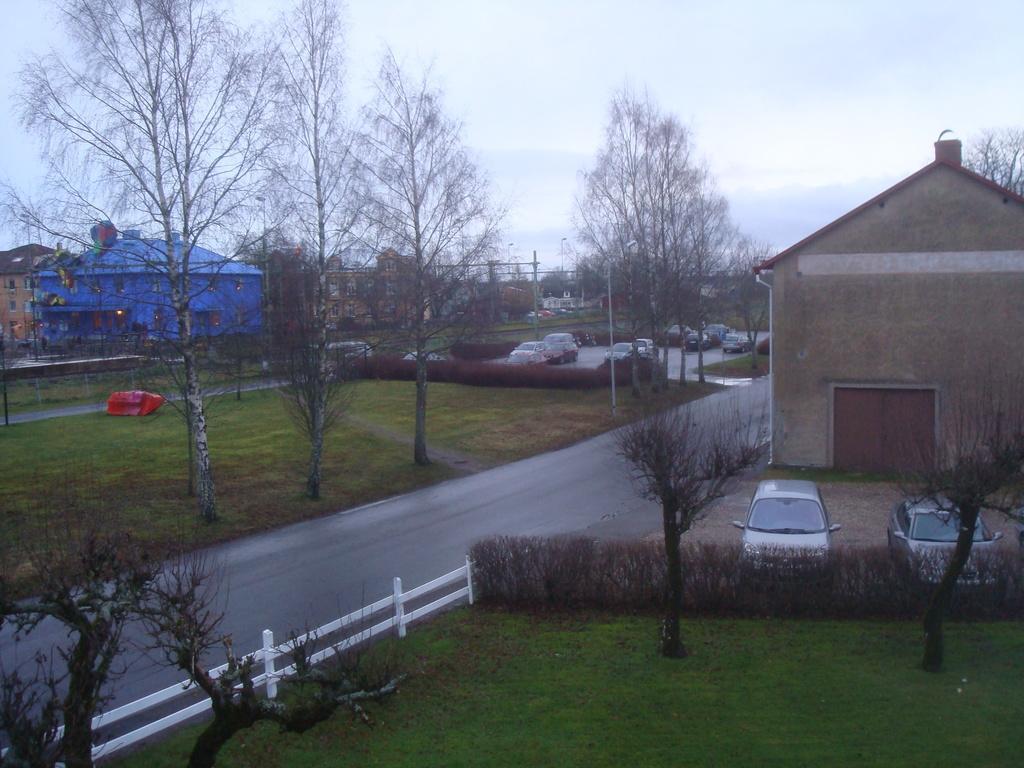Could you give a brief overview of what you see in this image? This is an outside view, in this image at the bottom there is grass, fence and some plants, cars, house and in the center there is a walkway. And in the background there are some houses, trees, vehicles grass and on the top of the image there is sky. 